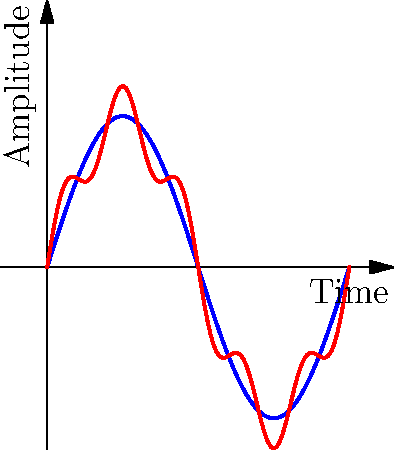Examine the sound wave patterns depicted in the graph. Which characteristic of vinyl recordings is evident when compared to digital audio, and how might this relate to the often-praised "warmth" of vinyl sound? 1. Observe the two waveforms:
   - Blue line represents digital audio
   - Red line represents vinyl recording

2. Notice the differences:
   - Digital audio (blue) shows a smooth sine wave
   - Vinyl recording (red) shows additional oscillations

3. These additional oscillations in the vinyl waveform represent:
   - Harmonic distortions
   - Subtle imperfections in the physical medium

4. Harmonic distortions in vinyl:
   - Add complexity to the sound
   - Introduce overtones and subtle variations

5. The "warmth" of vinyl sound:
   - Often attributed to these harmonic distortions
   - Creates a richer, more nuanced audio experience

6. Digital audio aims for perfect reproduction:
   - Lacks these natural distortions
   - Can sometimes be perceived as "colder" or "clinical"

7. In Afrobeat music:
   - Complex rhythms and instrumentations
   - These vinyl distortions can enhance the perceived richness of the sound

8. The graph shows:
   - Vinyl's additional harmonic content
   - Which contributes to its characteristic sound
Answer: Harmonic distortions in vinyl recordings add complexity and perceived warmth to the sound. 